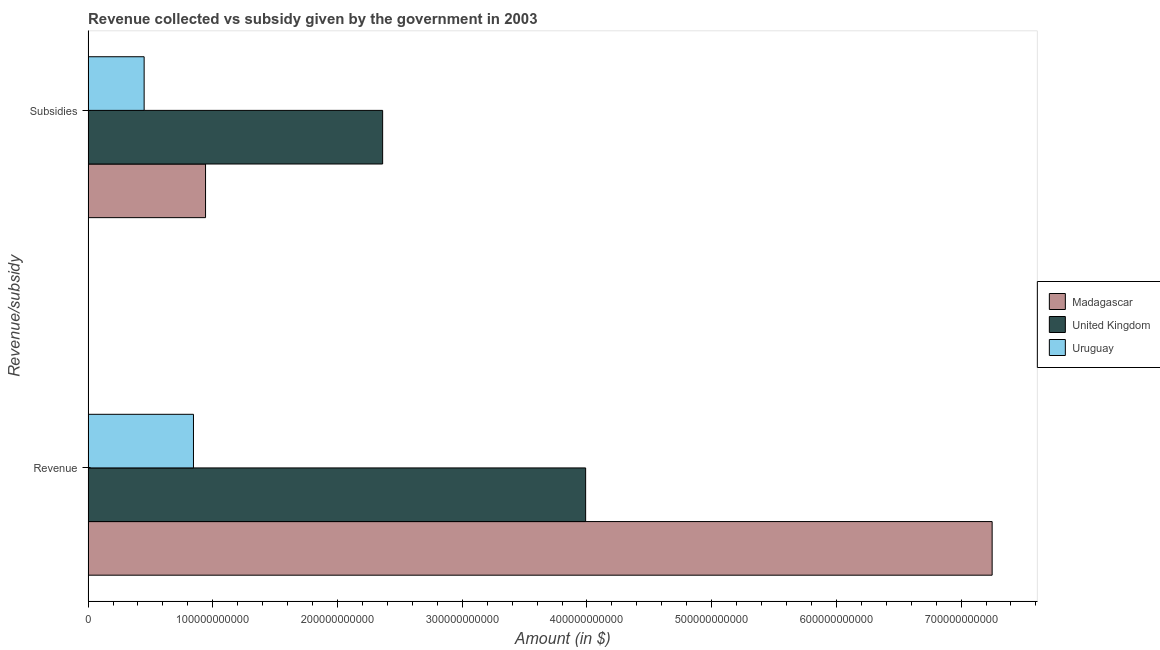How many different coloured bars are there?
Your answer should be very brief. 3. How many groups of bars are there?
Give a very brief answer. 2. Are the number of bars per tick equal to the number of legend labels?
Give a very brief answer. Yes. How many bars are there on the 1st tick from the top?
Your answer should be very brief. 3. How many bars are there on the 2nd tick from the bottom?
Give a very brief answer. 3. What is the label of the 1st group of bars from the top?
Make the answer very short. Subsidies. What is the amount of revenue collected in Uruguay?
Make the answer very short. 8.45e+1. Across all countries, what is the maximum amount of revenue collected?
Your response must be concise. 7.25e+11. Across all countries, what is the minimum amount of revenue collected?
Offer a very short reply. 8.45e+1. In which country was the amount of revenue collected maximum?
Make the answer very short. Madagascar. In which country was the amount of revenue collected minimum?
Your response must be concise. Uruguay. What is the total amount of revenue collected in the graph?
Your answer should be very brief. 1.21e+12. What is the difference between the amount of subsidies given in United Kingdom and that in Uruguay?
Offer a very short reply. 1.91e+11. What is the difference between the amount of subsidies given in United Kingdom and the amount of revenue collected in Uruguay?
Offer a very short reply. 1.52e+11. What is the average amount of revenue collected per country?
Provide a succinct answer. 4.03e+11. What is the difference between the amount of revenue collected and amount of subsidies given in United Kingdom?
Provide a short and direct response. 1.63e+11. In how many countries, is the amount of revenue collected greater than 560000000000 $?
Make the answer very short. 1. What is the ratio of the amount of revenue collected in Uruguay to that in United Kingdom?
Provide a succinct answer. 0.21. In how many countries, is the amount of revenue collected greater than the average amount of revenue collected taken over all countries?
Provide a succinct answer. 1. What does the 1st bar from the top in Revenue represents?
Offer a terse response. Uruguay. Are all the bars in the graph horizontal?
Make the answer very short. Yes. What is the difference between two consecutive major ticks on the X-axis?
Your answer should be very brief. 1.00e+11. Are the values on the major ticks of X-axis written in scientific E-notation?
Keep it short and to the point. No. Does the graph contain grids?
Provide a short and direct response. No. How are the legend labels stacked?
Provide a succinct answer. Vertical. What is the title of the graph?
Provide a succinct answer. Revenue collected vs subsidy given by the government in 2003. Does "New Zealand" appear as one of the legend labels in the graph?
Ensure brevity in your answer.  No. What is the label or title of the X-axis?
Give a very brief answer. Amount (in $). What is the label or title of the Y-axis?
Offer a very short reply. Revenue/subsidy. What is the Amount (in $) of Madagascar in Revenue?
Provide a short and direct response. 7.25e+11. What is the Amount (in $) in United Kingdom in Revenue?
Ensure brevity in your answer.  3.99e+11. What is the Amount (in $) of Uruguay in Revenue?
Your answer should be compact. 8.45e+1. What is the Amount (in $) of Madagascar in Subsidies?
Ensure brevity in your answer.  9.42e+1. What is the Amount (in $) in United Kingdom in Subsidies?
Keep it short and to the point. 2.36e+11. What is the Amount (in $) of Uruguay in Subsidies?
Keep it short and to the point. 4.49e+1. Across all Revenue/subsidy, what is the maximum Amount (in $) in Madagascar?
Your answer should be very brief. 7.25e+11. Across all Revenue/subsidy, what is the maximum Amount (in $) in United Kingdom?
Provide a succinct answer. 3.99e+11. Across all Revenue/subsidy, what is the maximum Amount (in $) in Uruguay?
Offer a terse response. 8.45e+1. Across all Revenue/subsidy, what is the minimum Amount (in $) of Madagascar?
Provide a succinct answer. 9.42e+1. Across all Revenue/subsidy, what is the minimum Amount (in $) of United Kingdom?
Provide a short and direct response. 2.36e+11. Across all Revenue/subsidy, what is the minimum Amount (in $) of Uruguay?
Give a very brief answer. 4.49e+1. What is the total Amount (in $) in Madagascar in the graph?
Provide a short and direct response. 8.19e+11. What is the total Amount (in $) of United Kingdom in the graph?
Ensure brevity in your answer.  6.35e+11. What is the total Amount (in $) in Uruguay in the graph?
Keep it short and to the point. 1.29e+11. What is the difference between the Amount (in $) of Madagascar in Revenue and that in Subsidies?
Your answer should be compact. 6.31e+11. What is the difference between the Amount (in $) of United Kingdom in Revenue and that in Subsidies?
Offer a terse response. 1.63e+11. What is the difference between the Amount (in $) of Uruguay in Revenue and that in Subsidies?
Your response must be concise. 3.96e+1. What is the difference between the Amount (in $) in Madagascar in Revenue and the Amount (in $) in United Kingdom in Subsidies?
Ensure brevity in your answer.  4.89e+11. What is the difference between the Amount (in $) in Madagascar in Revenue and the Amount (in $) in Uruguay in Subsidies?
Your response must be concise. 6.80e+11. What is the difference between the Amount (in $) in United Kingdom in Revenue and the Amount (in $) in Uruguay in Subsidies?
Your answer should be compact. 3.54e+11. What is the average Amount (in $) in Madagascar per Revenue/subsidy?
Make the answer very short. 4.10e+11. What is the average Amount (in $) of United Kingdom per Revenue/subsidy?
Make the answer very short. 3.18e+11. What is the average Amount (in $) of Uruguay per Revenue/subsidy?
Make the answer very short. 6.47e+1. What is the difference between the Amount (in $) of Madagascar and Amount (in $) of United Kingdom in Revenue?
Keep it short and to the point. 3.26e+11. What is the difference between the Amount (in $) of Madagascar and Amount (in $) of Uruguay in Revenue?
Make the answer very short. 6.40e+11. What is the difference between the Amount (in $) in United Kingdom and Amount (in $) in Uruguay in Revenue?
Your answer should be compact. 3.14e+11. What is the difference between the Amount (in $) of Madagascar and Amount (in $) of United Kingdom in Subsidies?
Provide a short and direct response. -1.42e+11. What is the difference between the Amount (in $) in Madagascar and Amount (in $) in Uruguay in Subsidies?
Provide a succinct answer. 4.92e+1. What is the difference between the Amount (in $) of United Kingdom and Amount (in $) of Uruguay in Subsidies?
Your response must be concise. 1.91e+11. What is the ratio of the Amount (in $) of Madagascar in Revenue to that in Subsidies?
Your answer should be compact. 7.7. What is the ratio of the Amount (in $) of United Kingdom in Revenue to that in Subsidies?
Offer a very short reply. 1.69. What is the ratio of the Amount (in $) of Uruguay in Revenue to that in Subsidies?
Provide a succinct answer. 1.88. What is the difference between the highest and the second highest Amount (in $) of Madagascar?
Make the answer very short. 6.31e+11. What is the difference between the highest and the second highest Amount (in $) of United Kingdom?
Provide a succinct answer. 1.63e+11. What is the difference between the highest and the second highest Amount (in $) in Uruguay?
Ensure brevity in your answer.  3.96e+1. What is the difference between the highest and the lowest Amount (in $) in Madagascar?
Offer a very short reply. 6.31e+11. What is the difference between the highest and the lowest Amount (in $) in United Kingdom?
Keep it short and to the point. 1.63e+11. What is the difference between the highest and the lowest Amount (in $) in Uruguay?
Give a very brief answer. 3.96e+1. 